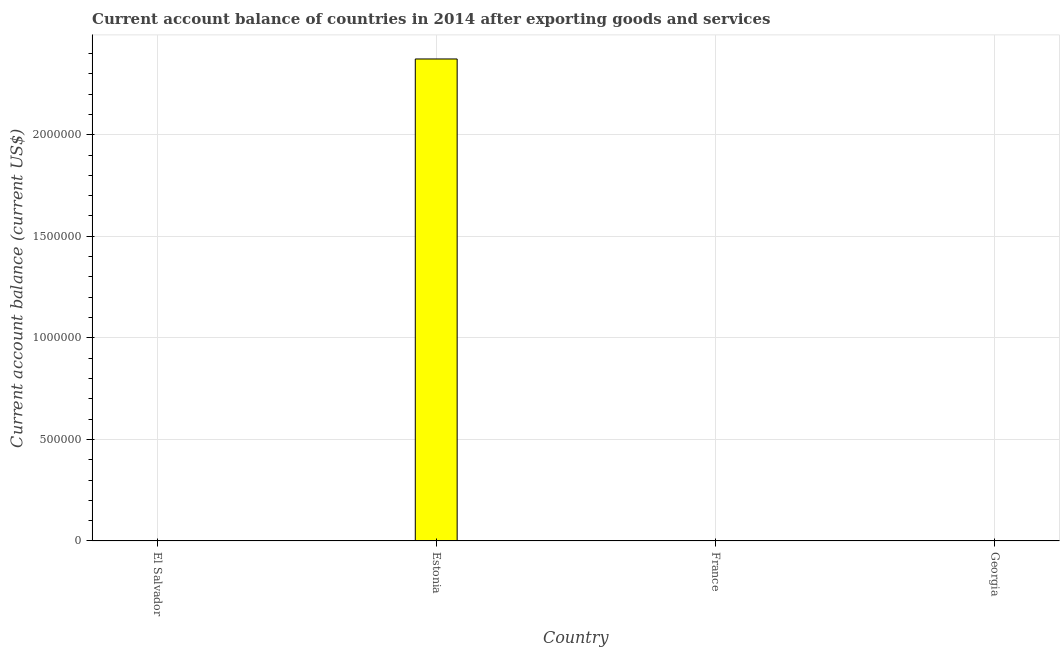Does the graph contain any zero values?
Give a very brief answer. Yes. What is the title of the graph?
Your response must be concise. Current account balance of countries in 2014 after exporting goods and services. What is the label or title of the X-axis?
Give a very brief answer. Country. What is the label or title of the Y-axis?
Your answer should be compact. Current account balance (current US$). Across all countries, what is the maximum current account balance?
Provide a succinct answer. 2.37e+06. In which country was the current account balance maximum?
Your answer should be compact. Estonia. What is the sum of the current account balance?
Your answer should be very brief. 2.37e+06. What is the average current account balance per country?
Ensure brevity in your answer.  5.93e+05. What is the median current account balance?
Make the answer very short. 0. In how many countries, is the current account balance greater than 1400000 US$?
Make the answer very short. 1. What is the difference between the highest and the lowest current account balance?
Offer a very short reply. 2.37e+06. In how many countries, is the current account balance greater than the average current account balance taken over all countries?
Your answer should be very brief. 1. Are all the bars in the graph horizontal?
Offer a very short reply. No. What is the difference between two consecutive major ticks on the Y-axis?
Ensure brevity in your answer.  5.00e+05. What is the Current account balance (current US$) of El Salvador?
Provide a short and direct response. 0. What is the Current account balance (current US$) in Estonia?
Offer a terse response. 2.37e+06. What is the Current account balance (current US$) in Georgia?
Ensure brevity in your answer.  0. 